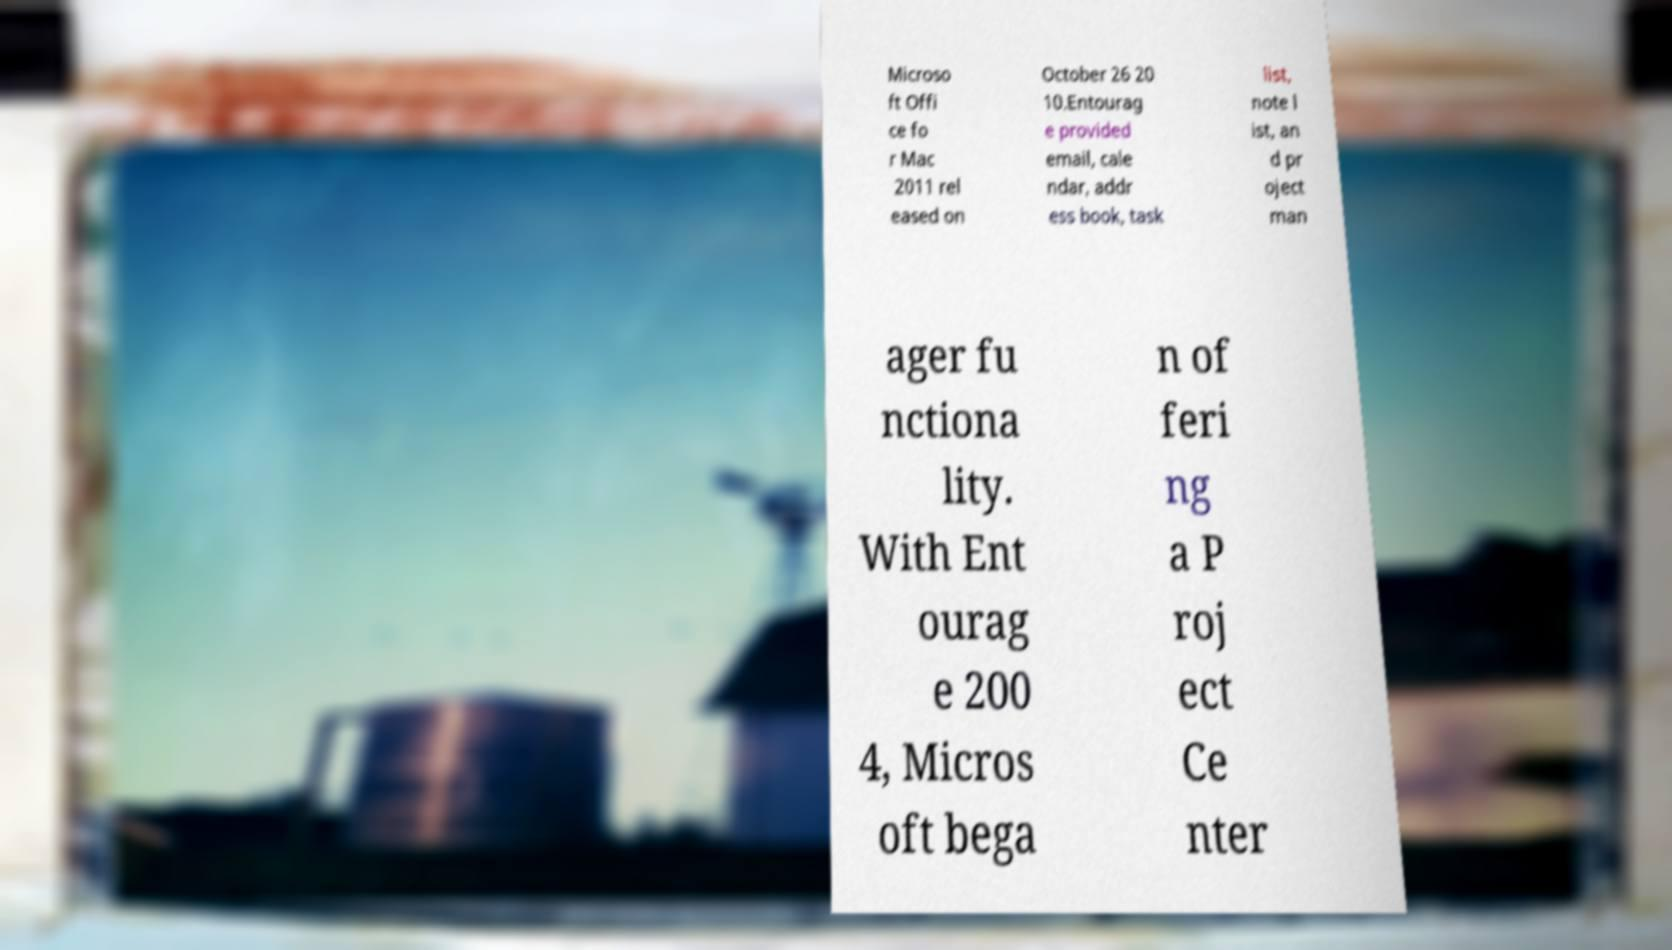What messages or text are displayed in this image? I need them in a readable, typed format. Microso ft Offi ce fo r Mac 2011 rel eased on October 26 20 10.Entourag e provided email, cale ndar, addr ess book, task list, note l ist, an d pr oject man ager fu nctiona lity. With Ent ourag e 200 4, Micros oft bega n of feri ng a P roj ect Ce nter 